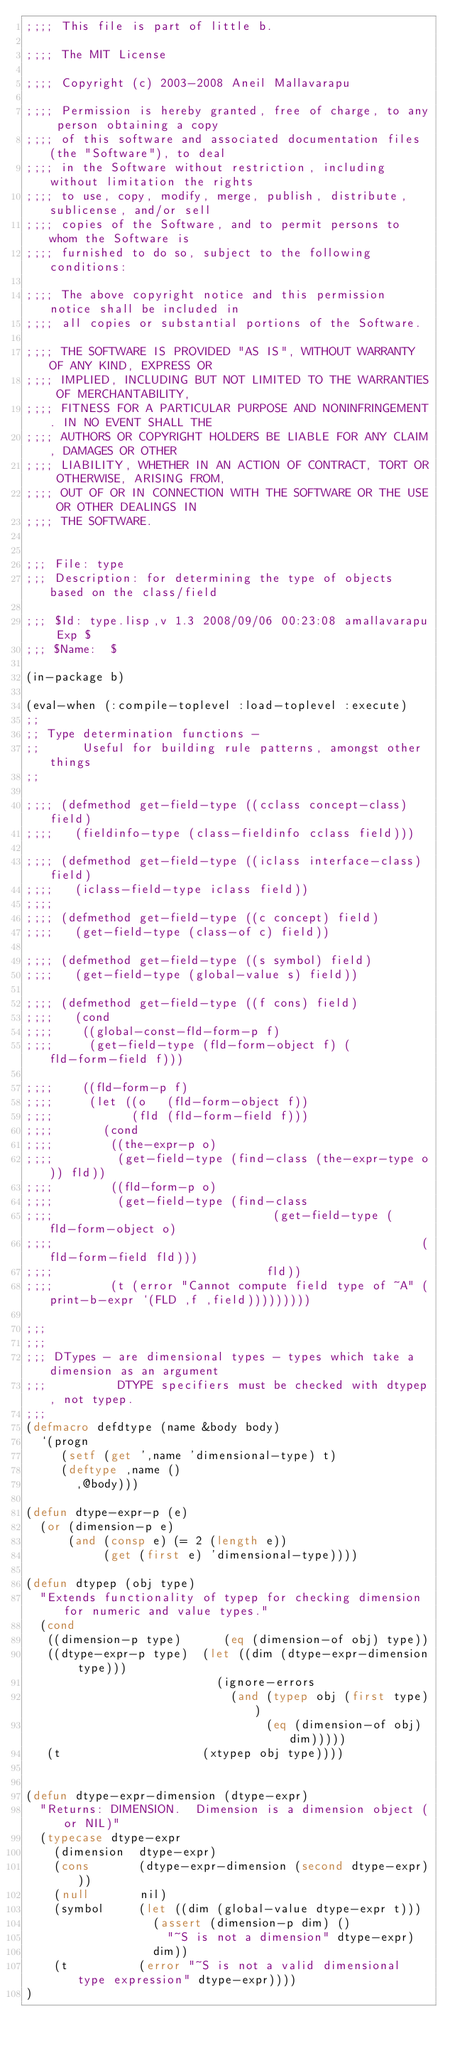Convert code to text. <code><loc_0><loc_0><loc_500><loc_500><_Lisp_>;;;; This file is part of little b.

;;;; The MIT License

;;;; Copyright (c) 2003-2008 Aneil Mallavarapu

;;;; Permission is hereby granted, free of charge, to any person obtaining a copy
;;;; of this software and associated documentation files (the "Software"), to deal
;;;; in the Software without restriction, including without limitation the rights
;;;; to use, copy, modify, merge, publish, distribute, sublicense, and/or sell
;;;; copies of the Software, and to permit persons to whom the Software is
;;;; furnished to do so, subject to the following conditions:

;;;; The above copyright notice and this permission notice shall be included in
;;;; all copies or substantial portions of the Software.

;;;; THE SOFTWARE IS PROVIDED "AS IS", WITHOUT WARRANTY OF ANY KIND, EXPRESS OR
;;;; IMPLIED, INCLUDING BUT NOT LIMITED TO THE WARRANTIES OF MERCHANTABILITY,
;;;; FITNESS FOR A PARTICULAR PURPOSE AND NONINFRINGEMENT. IN NO EVENT SHALL THE
;;;; AUTHORS OR COPYRIGHT HOLDERS BE LIABLE FOR ANY CLAIM, DAMAGES OR OTHER
;;;; LIABILITY, WHETHER IN AN ACTION OF CONTRACT, TORT OR OTHERWISE, ARISING FROM,
;;;; OUT OF OR IN CONNECTION WITH THE SOFTWARE OR THE USE OR OTHER DEALINGS IN
;;;; THE SOFTWARE.


;;; File: type
;;; Description: for determining the type of objects based on the class/field 

;;; $Id: type.lisp,v 1.3 2008/09/06 00:23:08 amallavarapu Exp $
;;; $Name:  $

(in-package b)

(eval-when (:compile-toplevel :load-toplevel :execute)
;;
;; Type determination functions - 
;;      Useful for building rule patterns, amongst other things
;;

;;;; (defmethod get-field-type ((cclass concept-class) field)
;;;;   (fieldinfo-type (class-fieldinfo cclass field)))

;;;; (defmethod get-field-type ((iclass interface-class) field)
;;;;   (iclass-field-type iclass field))
;;;;   
;;;; (defmethod get-field-type ((c concept) field)
;;;;   (get-field-type (class-of c) field))

;;;; (defmethod get-field-type ((s symbol) field)
;;;;   (get-field-type (global-value s) field))

;;;; (defmethod get-field-type ((f cons) field)
;;;;   (cond
;;;;    ((global-const-fld-form-p f)
;;;;     (get-field-type (fld-form-object f) (fld-form-field f)))

;;;;    ((fld-form-p f)
;;;;     (let ((o   (fld-form-object f))
;;;;           (fld (fld-form-field f)))
;;;;       (cond
;;;;        ((the-expr-p o)
;;;;         (get-field-type (find-class (the-expr-type o)) fld))
;;;;        ((fld-form-p o)
;;;;         (get-field-type (find-class 
;;;;                               (get-field-type (fld-form-object o)
;;;;                                                    (fld-form-field fld)))
;;;;                              fld))
;;;;        (t (error "Cannot compute field type of ~A" (print-b-expr `(FLD ,f ,field)))))))))

;;;
;;;
;;; DTypes - are dimensional types - types which take a dimension as an argument
;;;          DTYPE specifiers must be checked with dtypep, not typep.
;;;
(defmacro defdtype (name &body body)
  `(progn 
     (setf (get ',name 'dimensional-type) t)
     (deftype ,name ()
       ,@body)))

(defun dtype-expr-p (e)
  (or (dimension-p e)      
      (and (consp e) (= 2 (length e))
           (get (first e) 'dimensional-type))))

(defun dtypep (obj type)
  "Extends functionality of typep for checking dimension for numeric and value types."
  (cond
   ((dimension-p type)      (eq (dimension-of obj) type))
   ((dtype-expr-p type)  (let ((dim (dtype-expr-dimension type)))
                           (ignore-errors 
                             (and (typep obj (first type))
                                  (eq (dimension-of obj) dim)))))
   (t                    (xtypep obj type))))


(defun dtype-expr-dimension (dtype-expr)
  "Returns: DIMENSION.  Dimension is a dimension object (or NIL)"
  (typecase dtype-expr
    (dimension  dtype-expr)
    (cons       (dtype-expr-dimension (second dtype-expr)))
    (null       nil)
    (symbol     (let ((dim (global-value dtype-expr t)))
                  (assert (dimension-p dim) ()
                    "~S is not a dimension" dtype-expr)
                  dim))
    (t          (error "~S is not a valid dimensional type expression" dtype-expr))))
)
     
     
</code> 